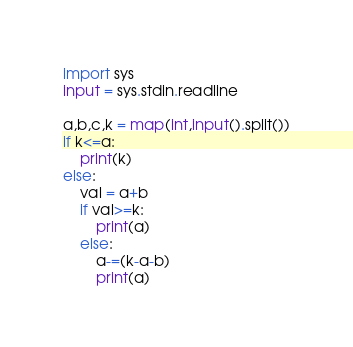<code> <loc_0><loc_0><loc_500><loc_500><_Python_>import sys
input = sys.stdin.readline

a,b,c,k = map(int,input().split())
if k<=a:
    print(k)
else:
    val = a+b
    if val>=k:
        print(a)
    else:
        a-=(k-a-b)
        print(a)
</code> 